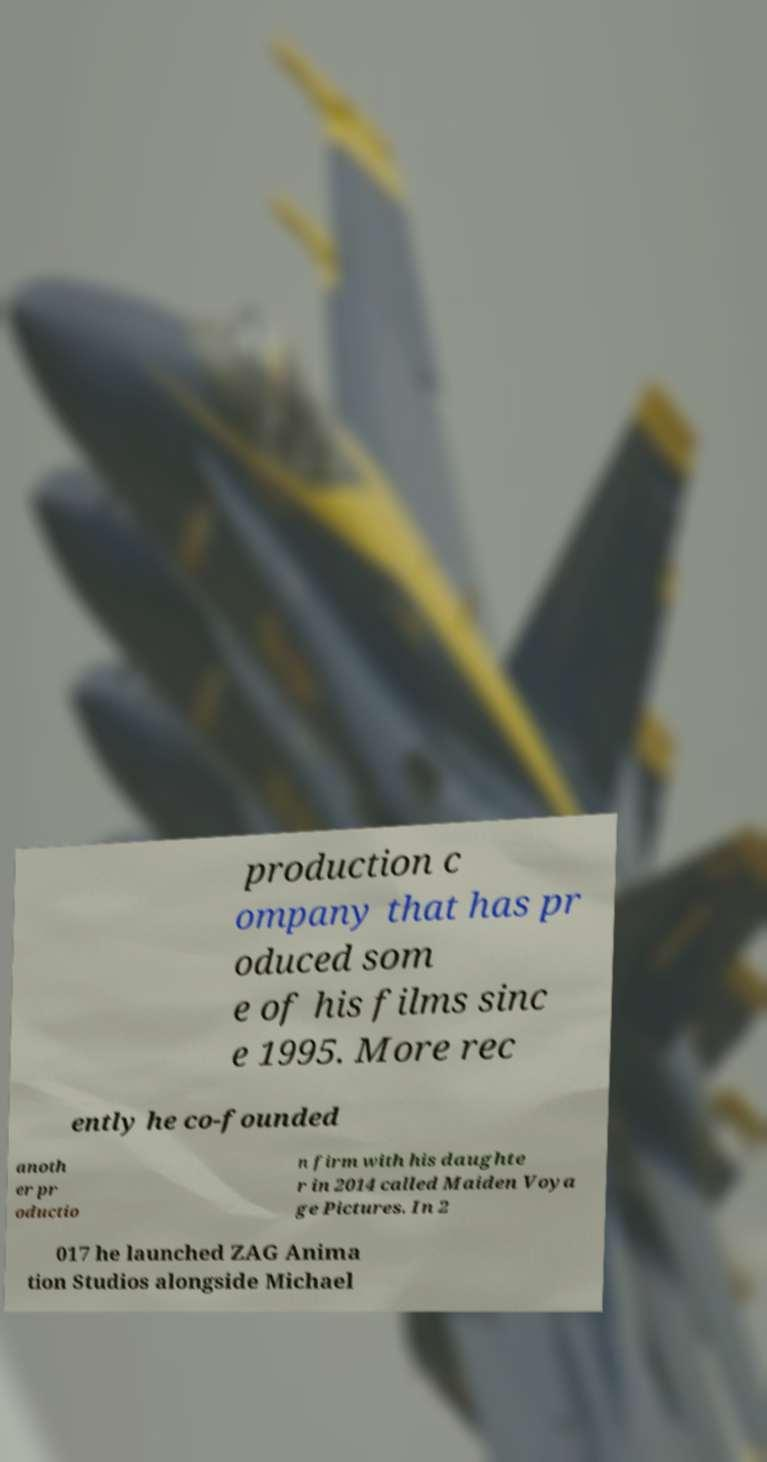For documentation purposes, I need the text within this image transcribed. Could you provide that? production c ompany that has pr oduced som e of his films sinc e 1995. More rec ently he co-founded anoth er pr oductio n firm with his daughte r in 2014 called Maiden Voya ge Pictures. In 2 017 he launched ZAG Anima tion Studios alongside Michael 